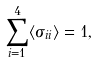Convert formula to latex. <formula><loc_0><loc_0><loc_500><loc_500>\sum _ { i = 1 } ^ { 4 } \langle \sigma _ { i i } \rangle = 1 ,</formula> 